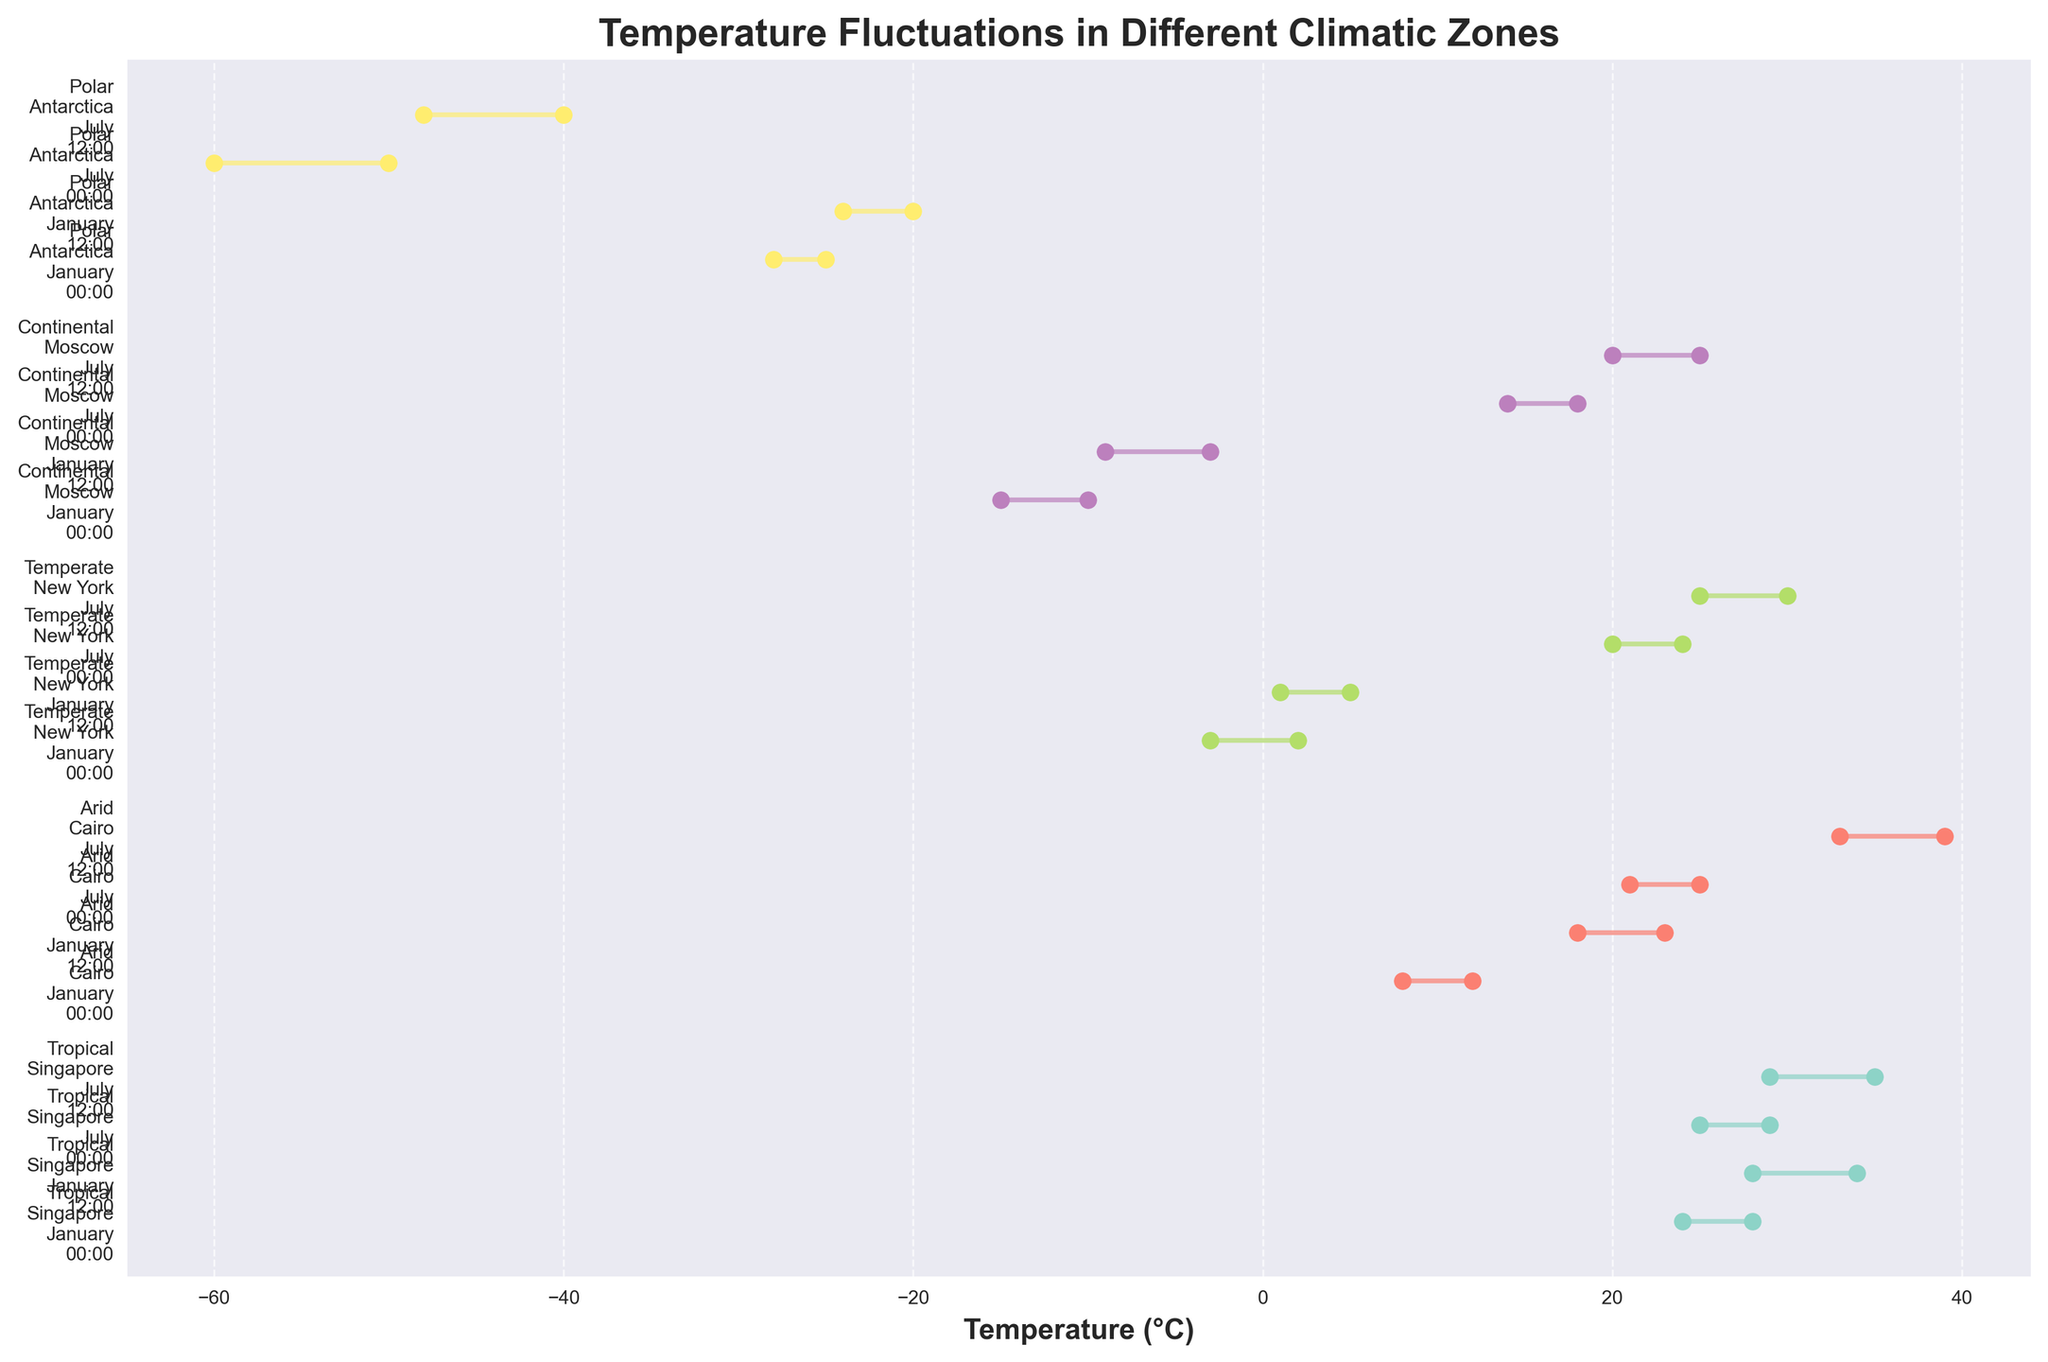What is the title of the figure? The title is typically displayed at the top of the figure. This specific figure has a title that describes the overall content.
Answer: Temperature Fluctuations in Different Climatic Zones How is the temperature data represented for each location, month, and time of day? The figure shows temperature fluctuations using lines and dots. Each line represents the range between the minimum and maximum temperatures, and the two dots indicate these minimum and maximum values on that line.
Answer: Lines and dots Which climatic zone has the most significant temperature range in January at 12:00? To find this, we locate the lines corresponding to January at 12:00 for each zone. We measure their lengths to determine which one spans the largest temperature range. From observation, the Arid zone (Cairo) spans from 18°C to 23°C, which is a 5°C range.
Answer: Arid (Cairo, 18°C - 23°C) What is the minimum recorded temperature across all climatic zones? We need to identify the lowest point on the x-axis for all the plotted temperature ranges. The Polar zone in Antarctica during July at 00:00 shows a minimum temperature of -60°C.
Answer: -60°C Which location experiences the highest maximum temperature, and in which month and time does this occur? We look for the highest point on the x-axis among all dots in the plot. The highest temperature recorded is in Cairo during July at 12:00, reaching 39°C.
Answer: Cairo, July at 12:00 Compare the temperature ranges between New York in January and July. Do mornings or afternoons show greater variability? For New York, identify the temperature ranges at 00:00 and 12:00 in January and July. January 00:00: -3°C to 2°C (5°C range); January 12:00: 1°C to 5°C (4°C range); July 00:00: 20°C to 24°C (4°C range); July 12:00: 25°C to 30°C (5°C range). Both months show an equal range difference between morning and evening (5°C vs. 4°C).
Answer: Equal variability in both months Which climatic zone shows temperatures below zero at any time of day? We examine each line to see if the minimum temperature drops below 0°C. The Temperate zone (New York in January), Continental zone (Moscow in January), and Polar zone (Antarctica in both January and July) all show temperatures below zero.
Answer: Temperate, Continental, and Polar How does the temperature range in Singapore compare between January and July at 00:00? For Singapore, we compare the temperature ranges at 00:00 for January and July. January 00:00: 24°C to 28°C (4°C range); July 00:00: 25°C to 29°C (4°C range). Both are the same.
Answer: Both are the same (4°C range) What is the temperature range in Moscow in July at 12:00? By locating the data for Moscow in July at 12:00, we see that the temperature ranges from 20°C to 25°C, which is a 5°C range.
Answer: 20°C to 25°C (5°C range) Analyze the temperature pattern in Antarctica between January and July. How does it vary throughout the day? For Antarctica, check the temperature ranges in both months (January and July). In January, at 00:00: -28°C to -25°C (3°C range), at 12:00: -24°C to -20°C (4°C range). In July, at 00:00: -60°C to -50°C (10°C range), and at 12:00: -48°C to -40°C (8°C range). Significantly colder in July with greater variability in the range.
Answer: Colder in July, more variable What is the average maximum temperature across all observations in the Tropical zone? There are four observations for the Tropical zone (Singapore). We sum up their maximum temperatures: 28°C + 34°C + 29°C + 35°C = 126°C. The average is 126°C / 4 = 31.5°C.
Answer: 31.5°C 